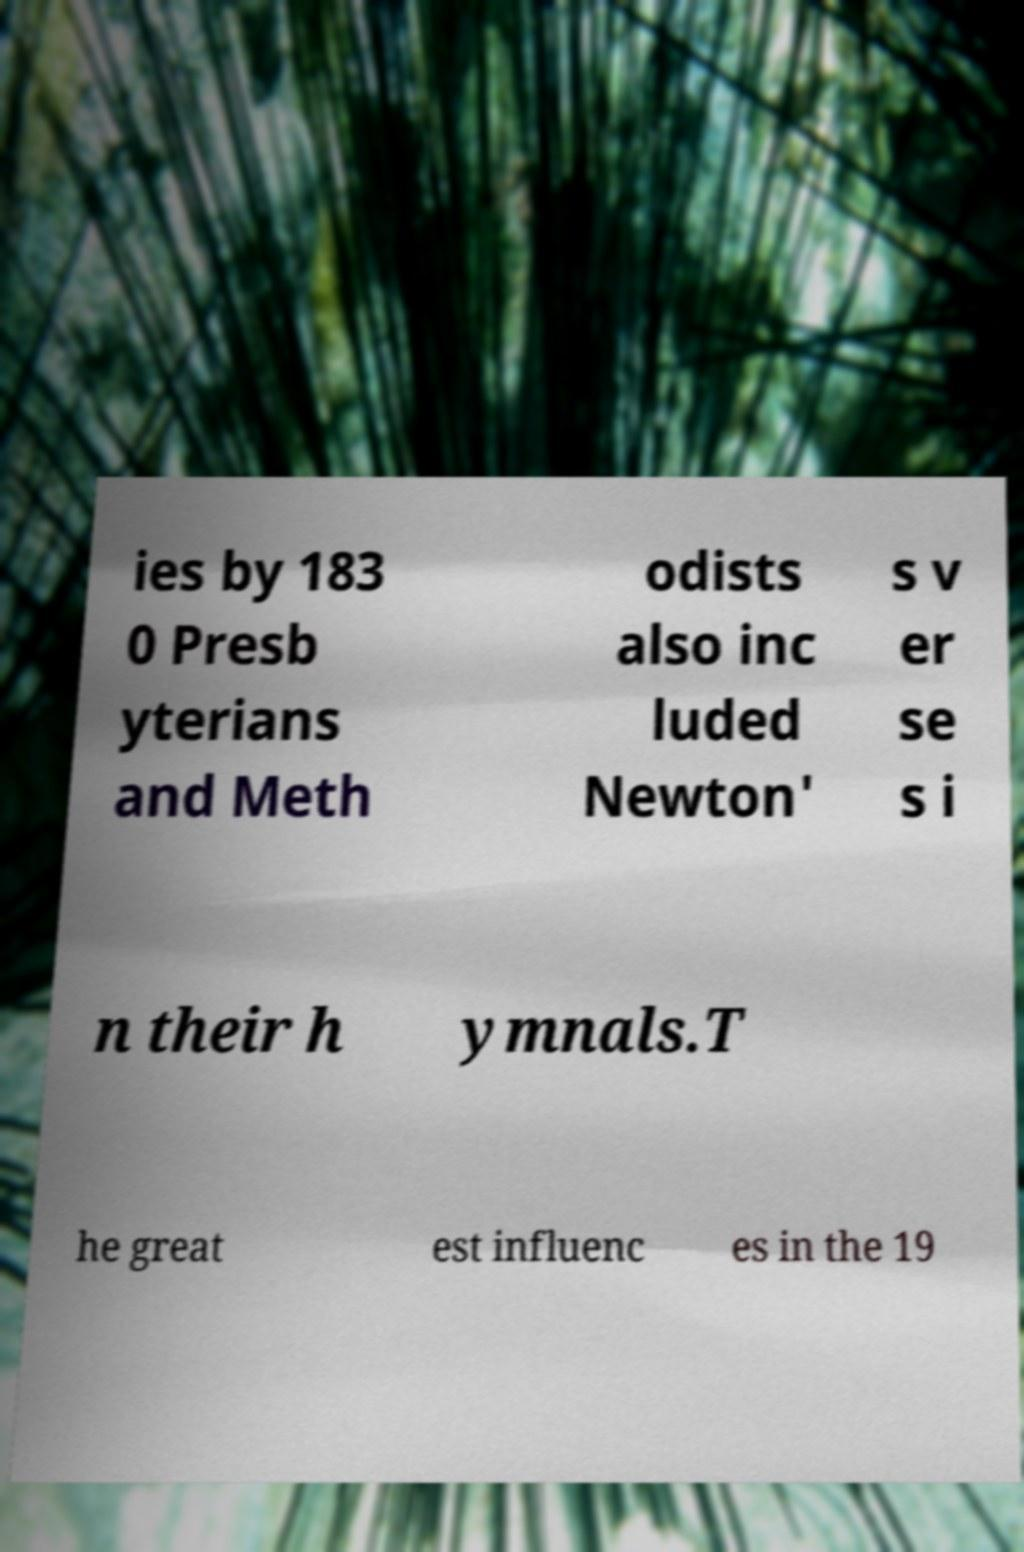Please read and relay the text visible in this image. What does it say? ies by 183 0 Presb yterians and Meth odists also inc luded Newton' s v er se s i n their h ymnals.T he great est influenc es in the 19 